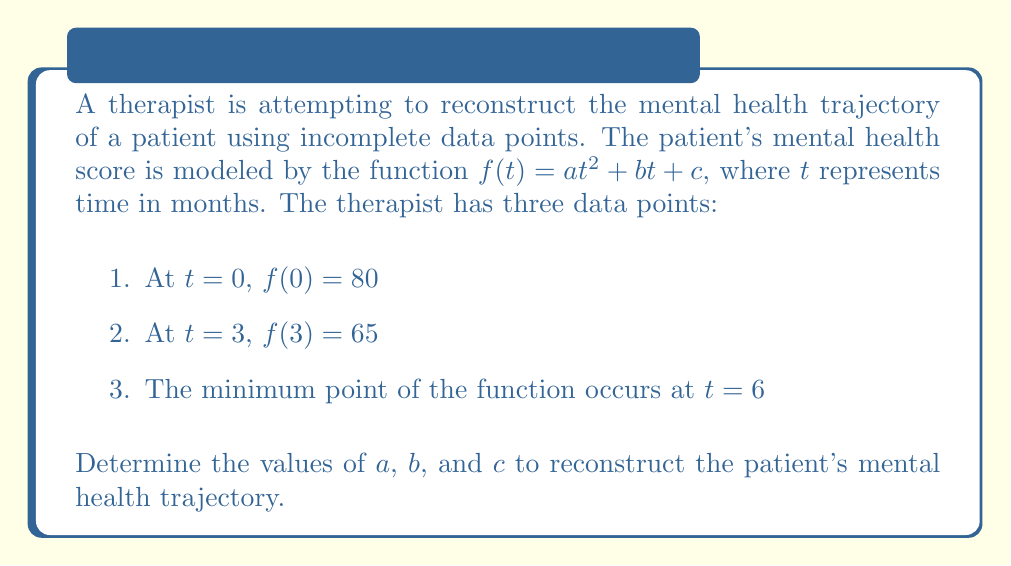Solve this math problem. Let's approach this step-by-step:

1) We know that $f(t) = at^2 + bt + c$

2) From the first data point:
   $f(0) = a(0)^2 + b(0) + c = c = 80$

3) From the second data point:
   $f(3) = a(3)^2 + b(3) + c = 65$
   $9a + 3b + 80 = 65$

4) The minimum point occurs at $t = 6$. At the minimum point, the derivative $f'(t) = 0$:
   $f'(t) = 2at + b$
   $2a(6) + b = 0$
   $12a + b = 0$

5) We now have a system of three equations:
   $c = 80$
   $9a + 3b + 80 = 65$
   $12a + b = 0$

6) From the third equation:
   $b = -12a$

7) Substituting this into the second equation:
   $9a + 3(-12a) + 80 = 65$
   $9a - 36a + 80 = 65$
   $-27a = -15$
   $a = \frac{5}{9}$

8) Now we can find $b$:
   $b = -12(\frac{5}{9}) = -\frac{20}{3}$

9) We already know $c = 80$

Therefore, the reconstructed mental health trajectory function is:

$f(t) = \frac{5}{9}t^2 - \frac{20}{3}t + 80$
Answer: $a = \frac{5}{9}$, $b = -\frac{20}{3}$, $c = 80$ 